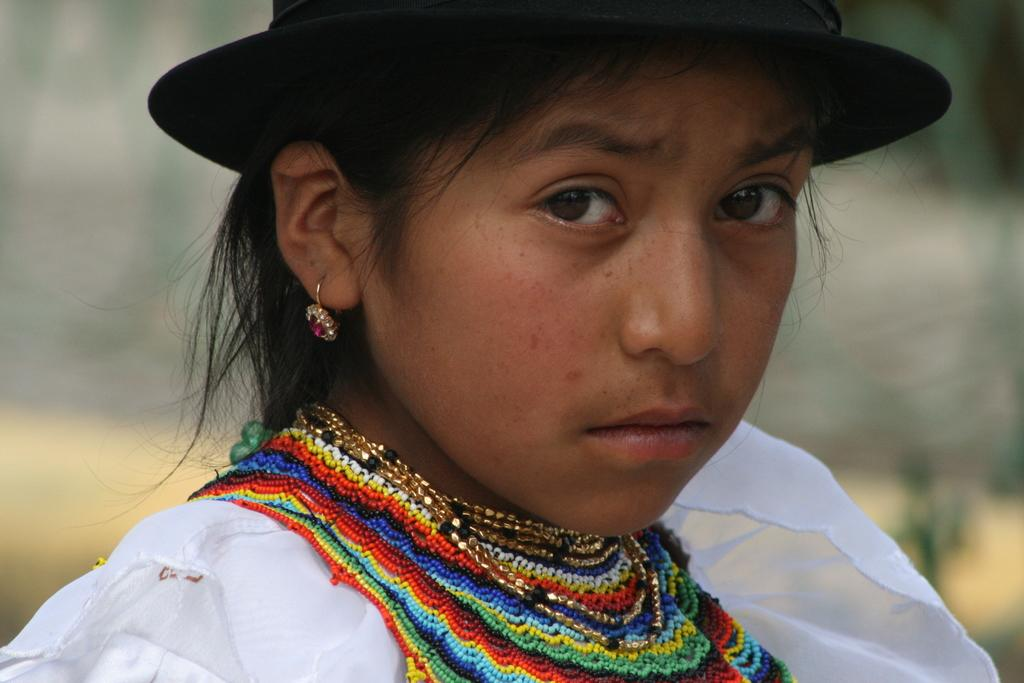Who is the main subject in the image? There is a girl in the image. What is the girl doing in the image? The girl is looking to one side. What is the girl wearing in the image? The girl is wearing a white dress and golden earrings. How many bottles of polish are visible in the image? There is no mention of any bottles of polish in the image, so it cannot be determined if any are visible. 